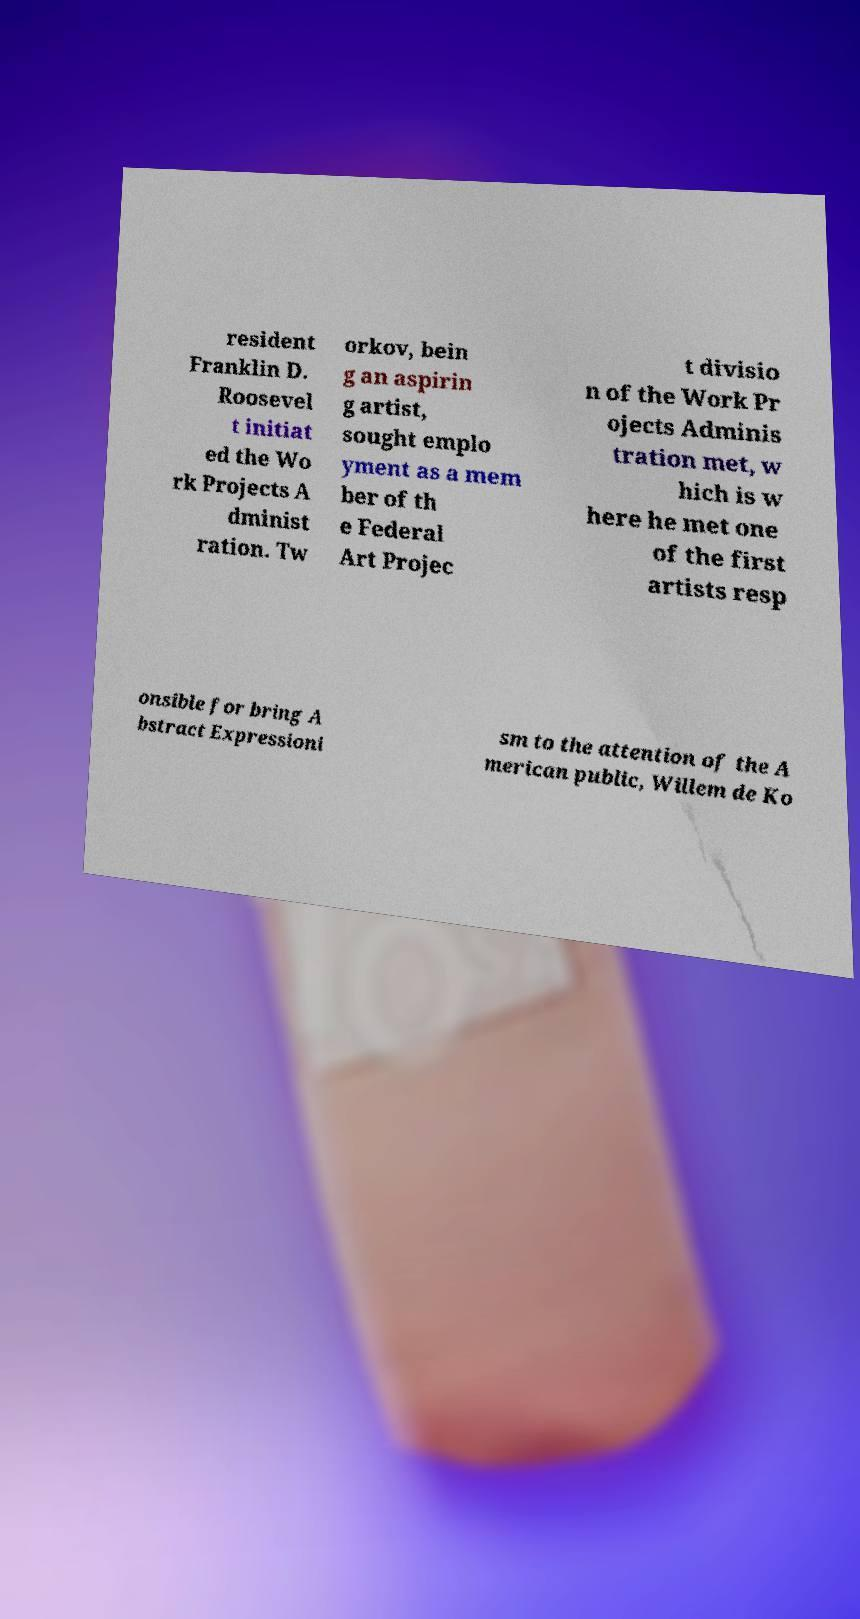Can you read and provide the text displayed in the image?This photo seems to have some interesting text. Can you extract and type it out for me? resident Franklin D. Roosevel t initiat ed the Wo rk Projects A dminist ration. Tw orkov, bein g an aspirin g artist, sought emplo yment as a mem ber of th e Federal Art Projec t divisio n of the Work Pr ojects Adminis tration met, w hich is w here he met one of the first artists resp onsible for bring A bstract Expressioni sm to the attention of the A merican public, Willem de Ko 